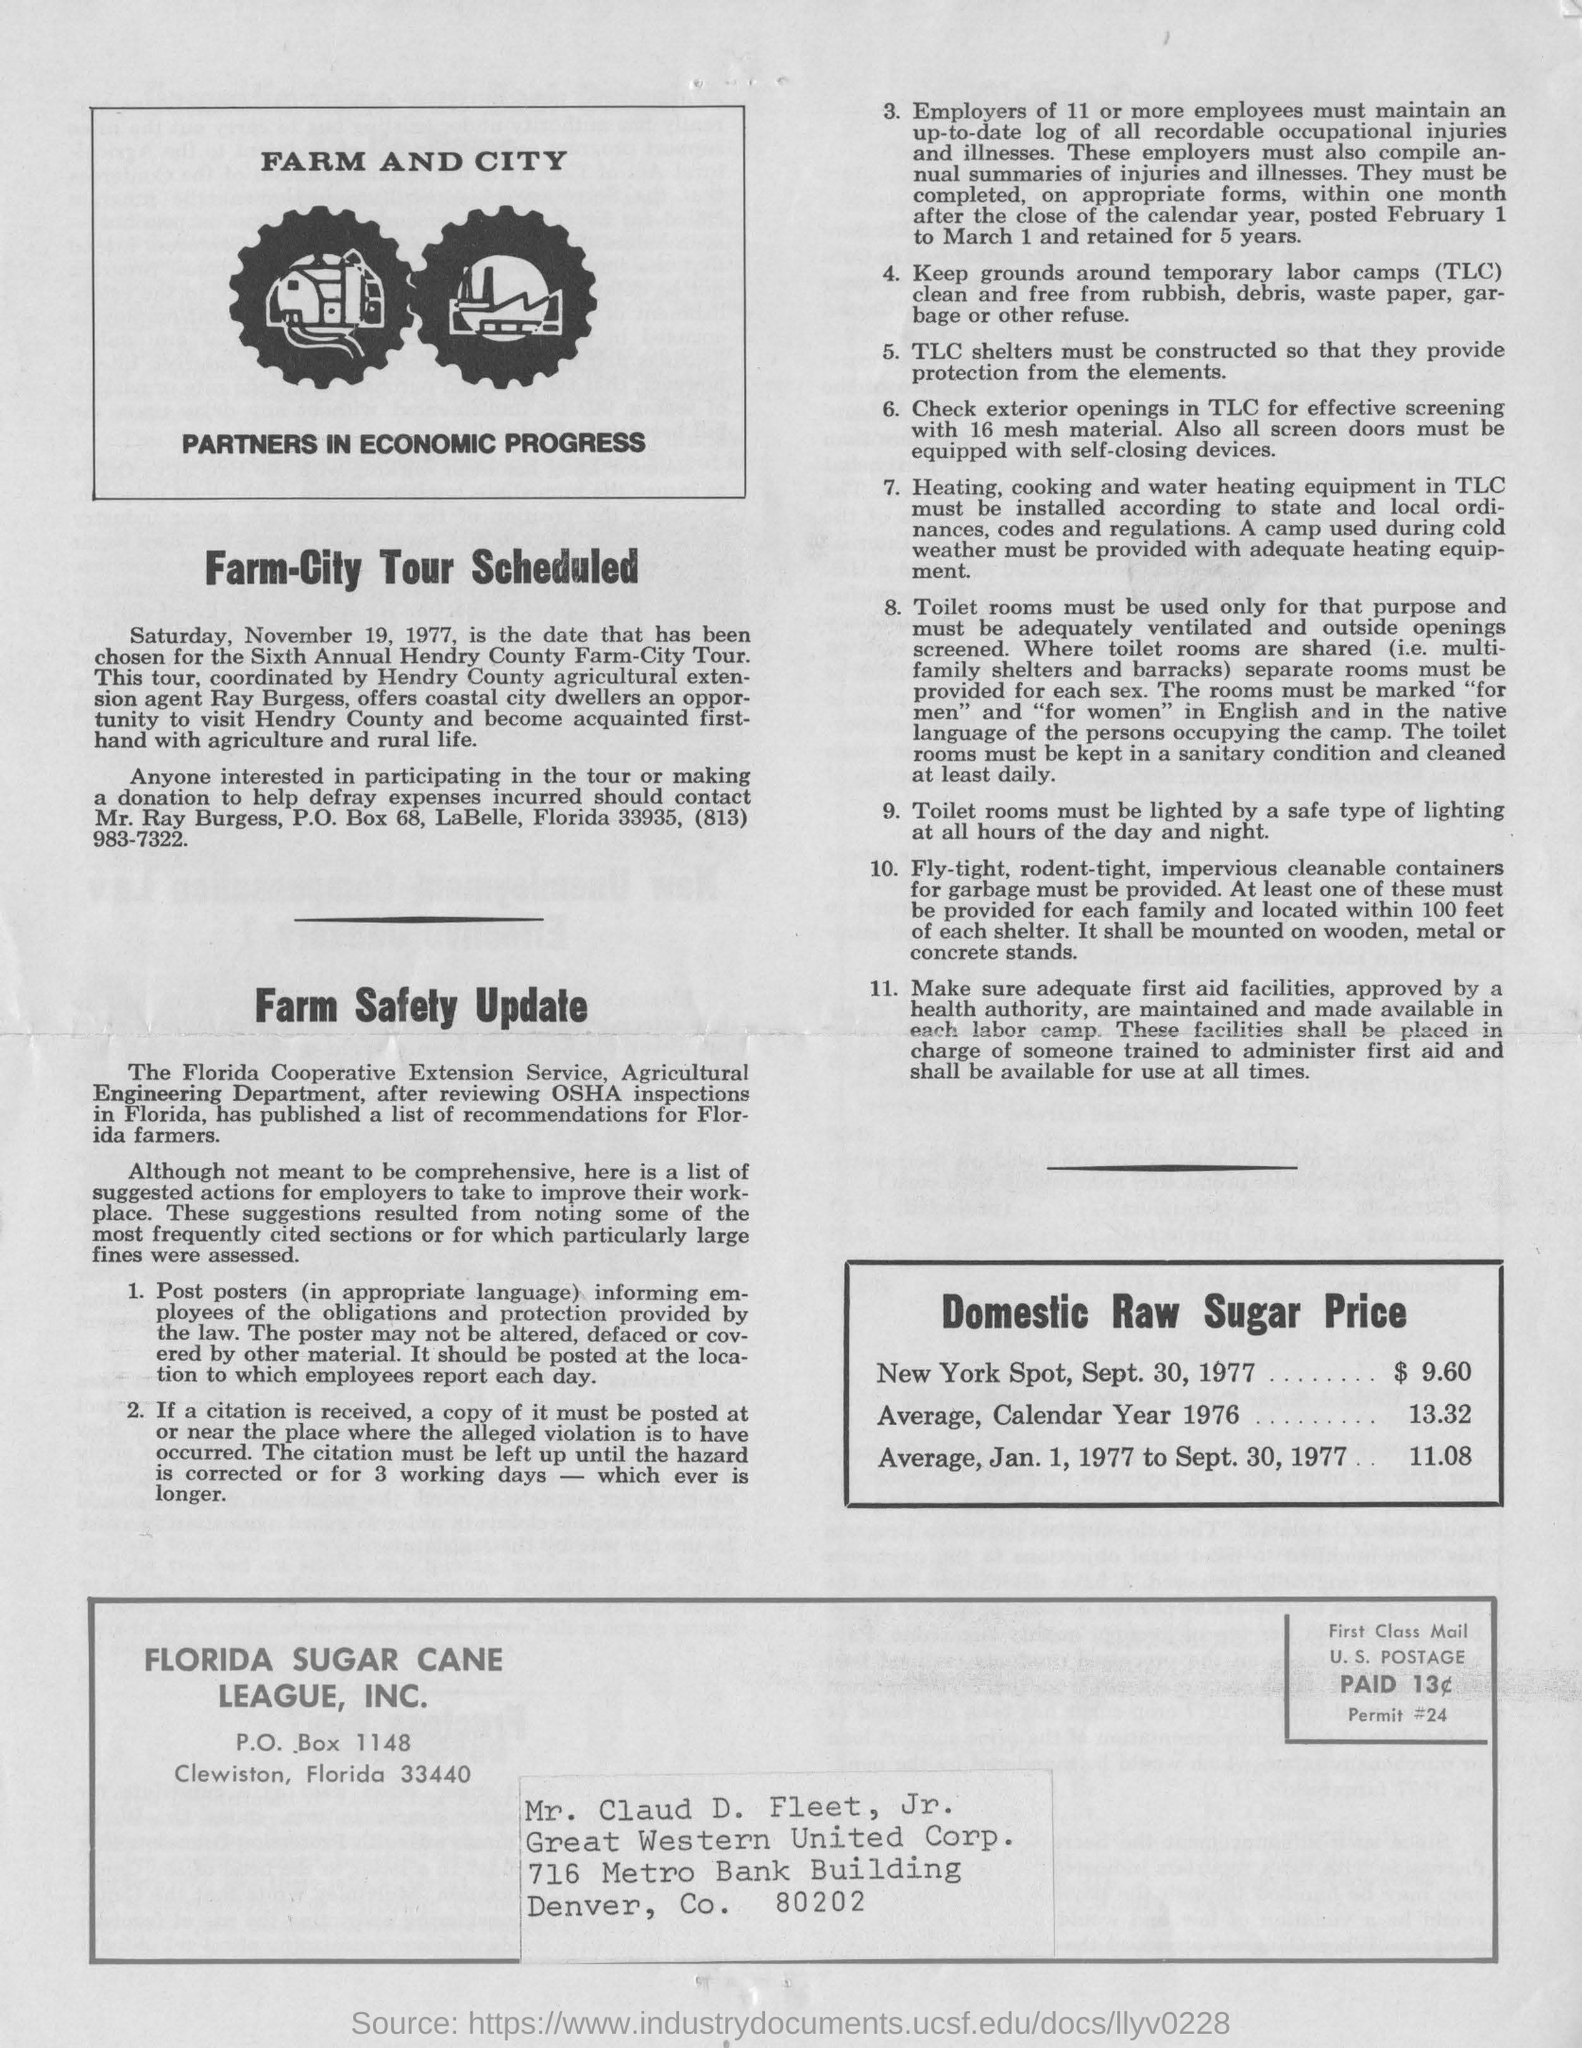Which date has been chosen for the sixth annual henry country farm city tour?
Your response must be concise. Saturday, November 19, 1977. Who is agricultural extension agent offers coastal city dwellers an opportunity to visit hendry county ?
Your answer should be compact. Ray Burgess. What is the contact address for participation in tour or making a donation to help defray expenses?
Your answer should be very brief. Mr. Ray Burgess, P.O. Box 68, LaBelle, Florida 33935, (813) 983-7322. What does TLC stands for?
Provide a short and direct response. Temporary labor camps. What is the domestic raw sugar price at new york spot on sept.30,1977?
Offer a terse response. $ 9.60. 